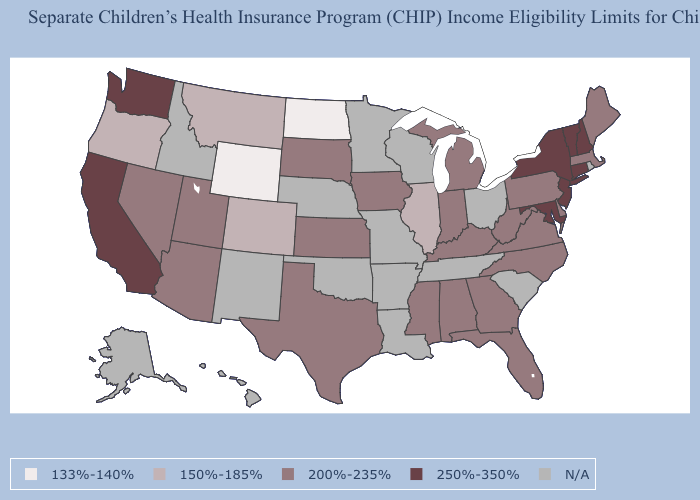Name the states that have a value in the range N/A?
Answer briefly. Alaska, Arkansas, Hawaii, Idaho, Louisiana, Minnesota, Missouri, Nebraska, New Mexico, Ohio, Oklahoma, Rhode Island, South Carolina, Tennessee, Wisconsin. Name the states that have a value in the range 133%-140%?
Be succinct. North Dakota, Wyoming. What is the value of New York?
Give a very brief answer. 250%-350%. Name the states that have a value in the range N/A?
Answer briefly. Alaska, Arkansas, Hawaii, Idaho, Louisiana, Minnesota, Missouri, Nebraska, New Mexico, Ohio, Oklahoma, Rhode Island, South Carolina, Tennessee, Wisconsin. Does Colorado have the lowest value in the USA?
Keep it brief. No. What is the value of Arkansas?
Answer briefly. N/A. What is the highest value in states that border Mississippi?
Quick response, please. 200%-235%. How many symbols are there in the legend?
Write a very short answer. 5. Name the states that have a value in the range N/A?
Keep it brief. Alaska, Arkansas, Hawaii, Idaho, Louisiana, Minnesota, Missouri, Nebraska, New Mexico, Ohio, Oklahoma, Rhode Island, South Carolina, Tennessee, Wisconsin. What is the value of Michigan?
Keep it brief. 200%-235%. Name the states that have a value in the range 133%-140%?
Give a very brief answer. North Dakota, Wyoming. What is the highest value in states that border Florida?
Give a very brief answer. 200%-235%. What is the highest value in states that border Massachusetts?
Answer briefly. 250%-350%. 